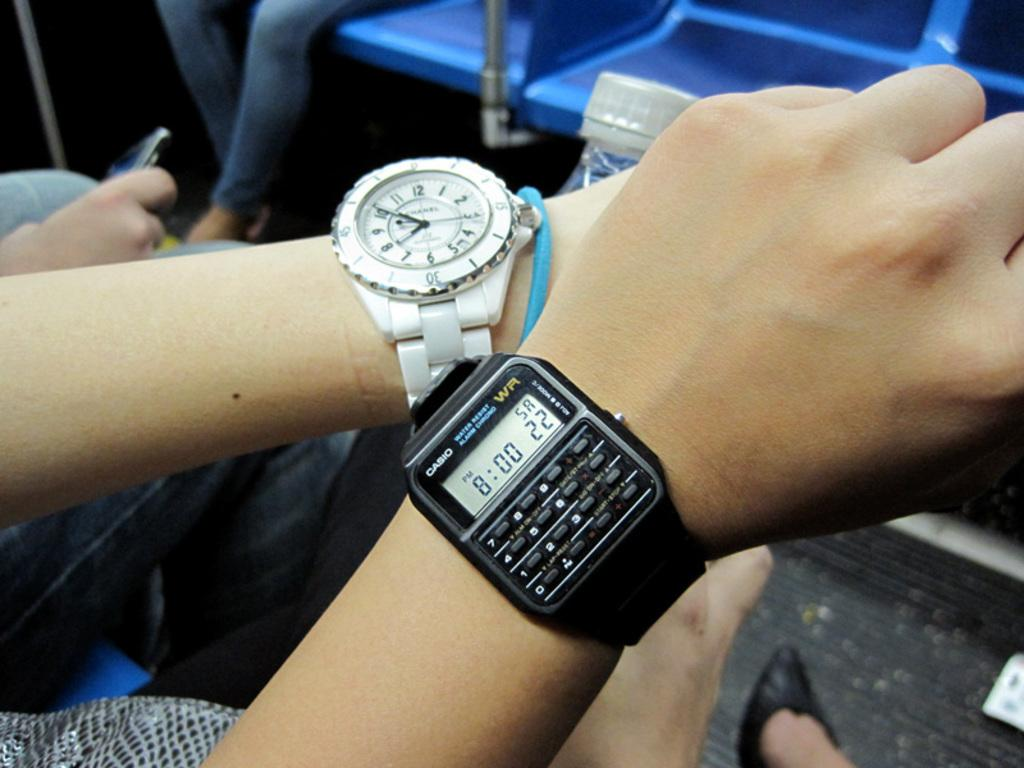<image>
Share a concise interpretation of the image provided. two arms of people wearing watches by channel and casio 